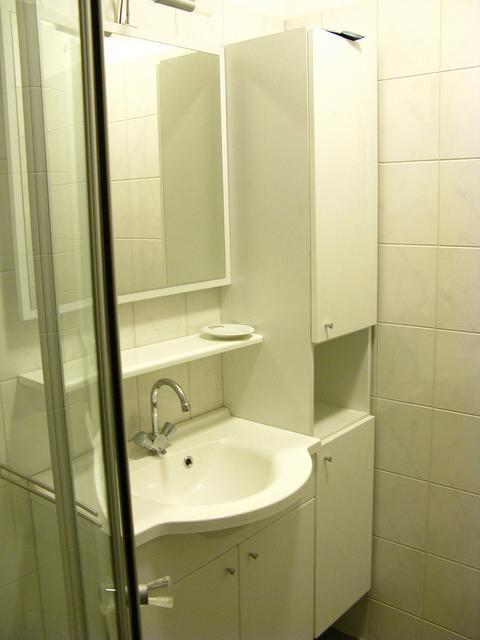How many sinks are in the photo?
Give a very brief answer. 1. 